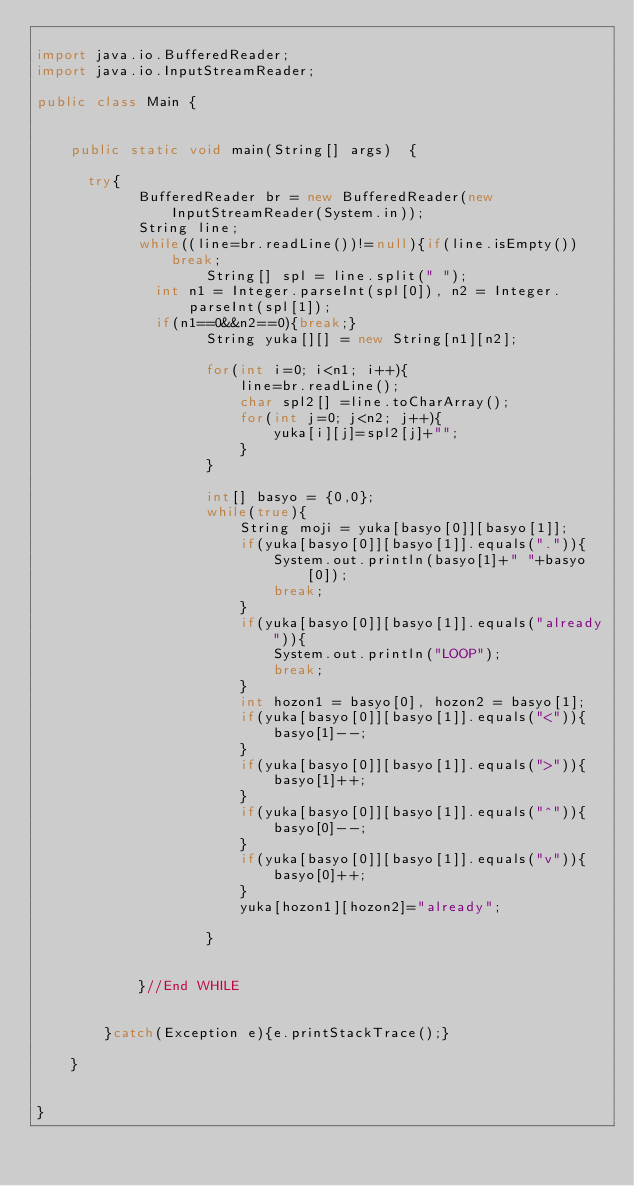Convert code to text. <code><loc_0><loc_0><loc_500><loc_500><_Java_>
import java.io.BufferedReader;
import java.io.InputStreamReader;

public class Main {

  
    public static void main(String[] args)  {

    	try{
            BufferedReader br = new BufferedReader(new InputStreamReader(System.in));
            String line;
            while((line=br.readLine())!=null){if(line.isEmpty())break;
                    String[] spl = line.split(" ");
	            int n1 = Integer.parseInt(spl[0]), n2 = Integer.parseInt(spl[1]);
	            if(n1==0&&n2==0){break;}
                    String yuka[][] = new String[n1][n2];
                    
                    for(int i=0; i<n1; i++){
                        line=br.readLine();
                        char spl2[] =line.toCharArray();
                        for(int j=0; j<n2; j++){
                            yuka[i][j]=spl2[j]+"";
                        }
                    }
                    
                    int[] basyo = {0,0};
                    while(true){
                        String moji = yuka[basyo[0]][basyo[1]];
                        if(yuka[basyo[0]][basyo[1]].equals(".")){
                            System.out.println(basyo[1]+" "+basyo[0]);
                            break;
                        }
                        if(yuka[basyo[0]][basyo[1]].equals("already")){
                            System.out.println("LOOP");
                            break;
                        }
                        int hozon1 = basyo[0], hozon2 = basyo[1];
                        if(yuka[basyo[0]][basyo[1]].equals("<")){
                            basyo[1]--;
                        }
                        if(yuka[basyo[0]][basyo[1]].equals(">")){
                            basyo[1]++;
                        }
                        if(yuka[basyo[0]][basyo[1]].equals("^")){
                            basyo[0]--;
                        }
                        if(yuka[basyo[0]][basyo[1]].equals("v")){
                            basyo[0]++;
                        }
                        yuka[hozon1][hozon2]="already";

                    }
                    
                    
            }//End WHILE


        }catch(Exception e){e.printStackTrace();}

    }


}</code> 